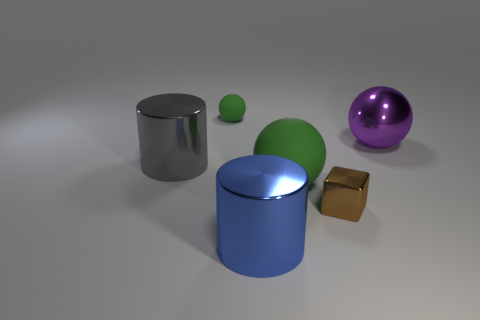Is the big matte thing the same color as the shiny cube?
Your answer should be very brief. No. The tiny green rubber object is what shape?
Provide a short and direct response. Sphere. Are there any large balls of the same color as the shiny block?
Your response must be concise. No. Is the number of blue cylinders in front of the large green object greater than the number of balls?
Offer a very short reply. No. There is a gray metal thing; is its shape the same as the tiny green thing that is right of the gray metal thing?
Provide a short and direct response. No. Are there any small red shiny spheres?
Your response must be concise. No. What number of small things are purple things or blue metal things?
Provide a succinct answer. 0. Are there more metal blocks behind the shiny block than matte spheres that are in front of the big rubber object?
Provide a succinct answer. No. Does the large blue cylinder have the same material as the tiny object behind the large green rubber sphere?
Keep it short and to the point. No. What is the color of the shiny block?
Offer a very short reply. Brown. 